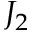<formula> <loc_0><loc_0><loc_500><loc_500>J _ { 2 }</formula> 